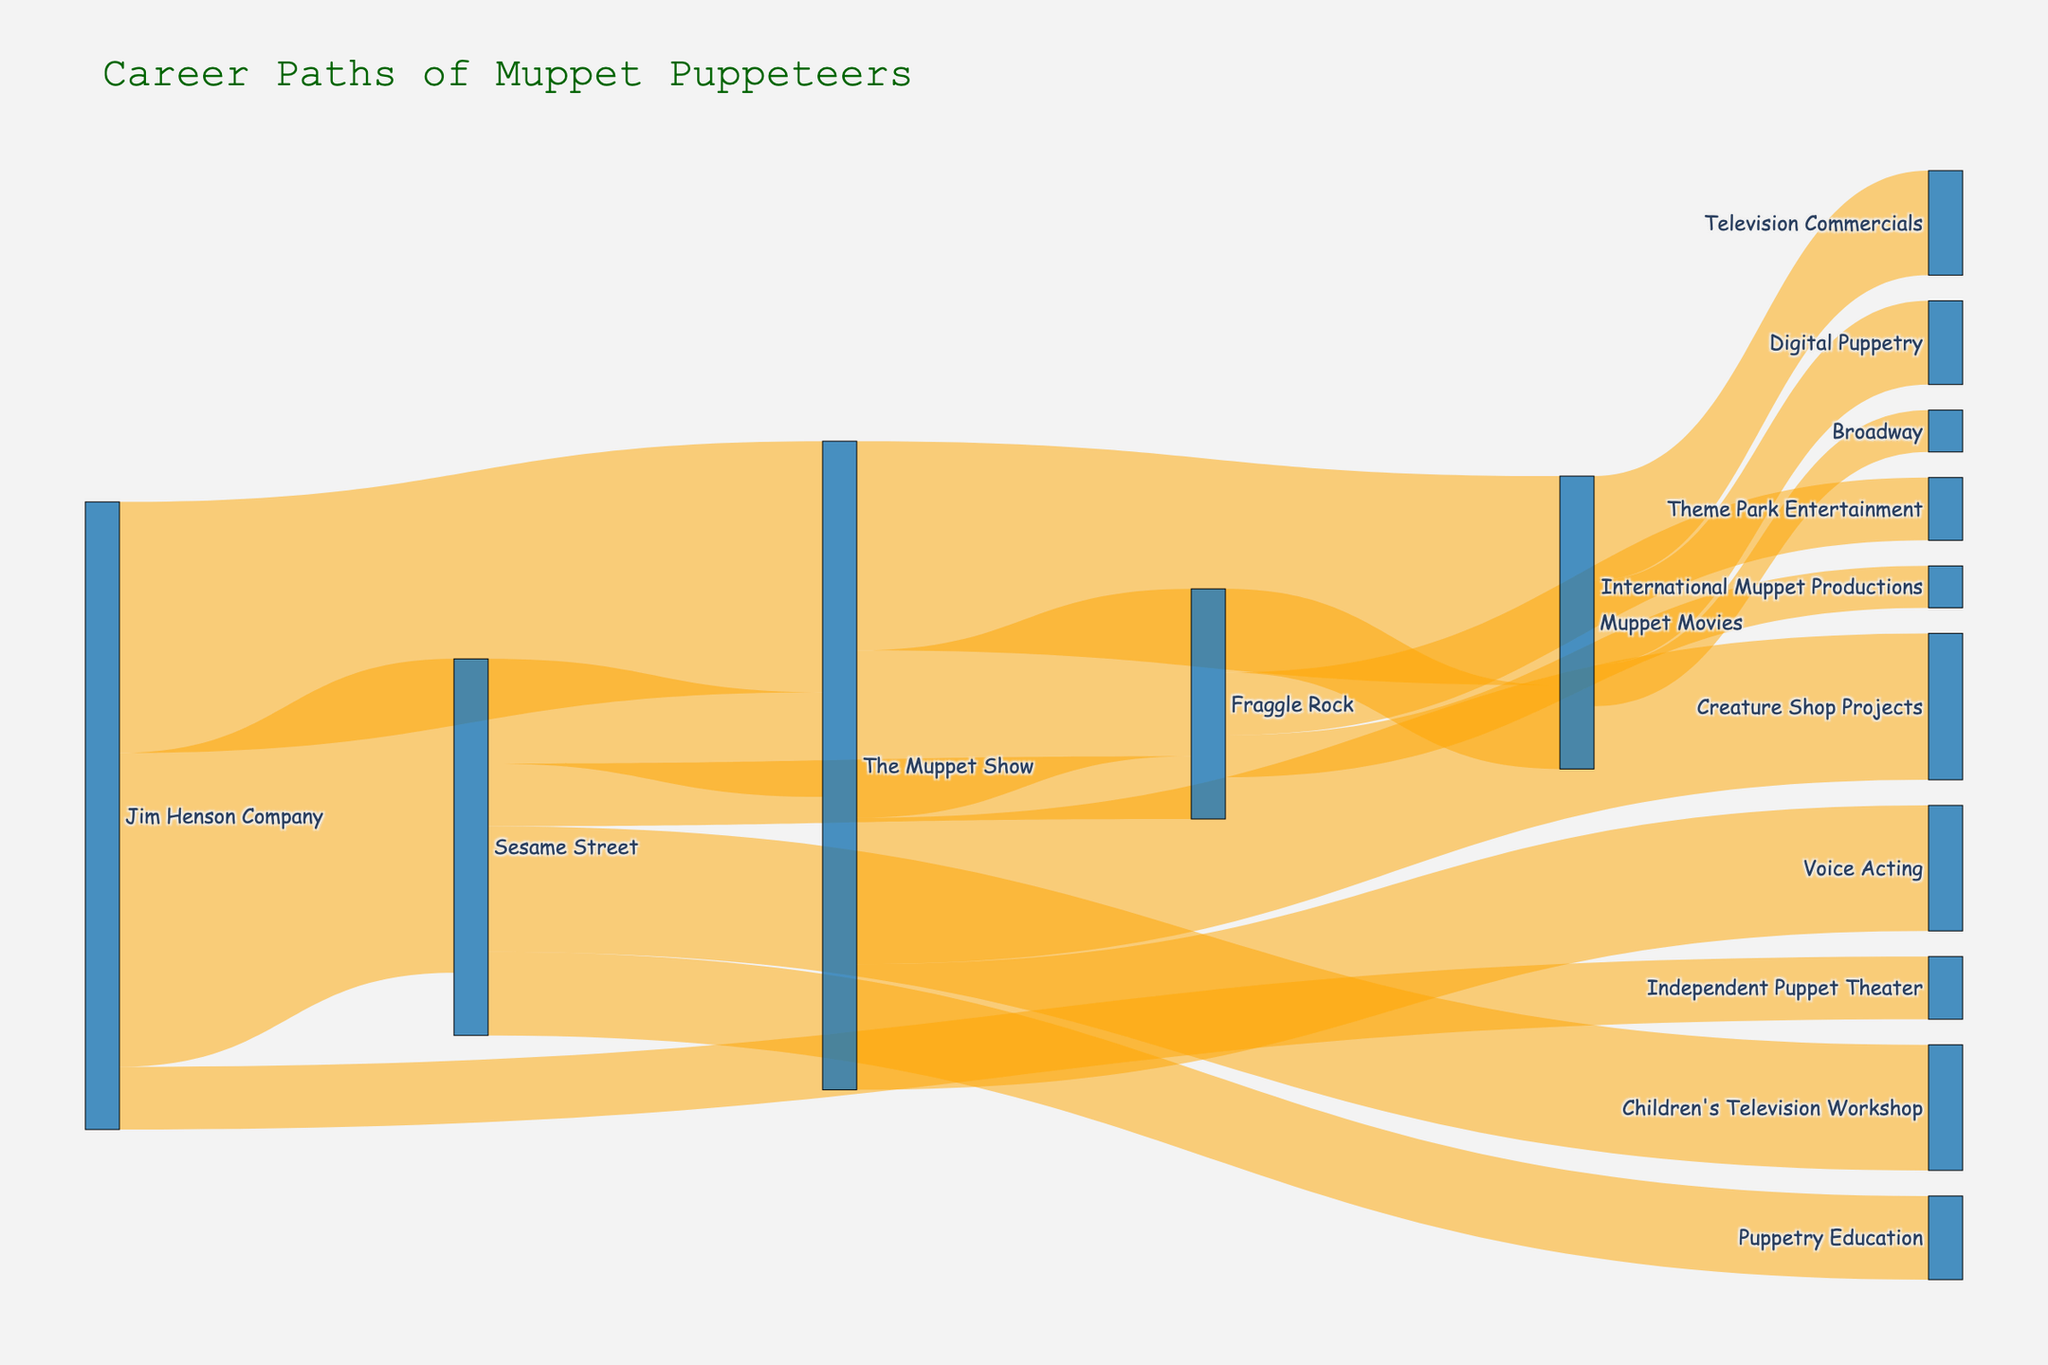How many career transitions from the Jim Henson Company to other entities are shown? There are four transitions starting from the Jim Henson Company: to Sesame Street (15), The Muppet Show (12), Independent Puppet Theater (3), and one to an unspecified location. So there are a total of 4 transitions.
Answer: 4 Which transition has the highest value in the Sankey diagram? Scan through all the 'value' figures associated with different transitions visually. The highest value is from the Jim Henson Company to Sesame Street with a value of 15.
Answer: Jim Henson Company to Sesame Street How many puppeteers transitioned from Sesame Street to either Fraggle Rock or The Muppet Show? The transition value from Sesame Street to Fraggle Rock is 3, and to The Muppet Show is 5. Adding these gives 3 + 5 = 8.
Answer: 8 Between The Muppet Show and Fraggle Rock, which has more transitions to Muppet Movies? The transition value from The Muppet Show to Muppet Movies is 10, and from Fraggle Rock to Muppet Movies is 4. 10 is greater than 4.
Answer: The Muppet Show What is the sum of all transitions originating from The Muppet Show? The transitions originating from The Muppet Show are to Fraggle Rock (8), Muppet Movies (10), Voice Acting (6), and Creature Shop Projects (7). Summing these: 8 + 10 + 6 + 7 = 31.
Answer: 31 Which category has the most diverse career paths (i.e., the most target nodes)? By counting the number of unique target nodes for each source node, The Muppet Show connects to Fraggle Rock, Muppet Movies, Voice Acting, and Creature Shop Projects. It has 4 different targets, the same as the Jim Henson Company. Both have the highest diversity in paths with 4 targets each.
Answer: The Muppet Show and Jim Henson Company What is the difference in transition values between The Muppet Show and Sesame Street leading to Fraggle Rock? The value from The Muppet Show to Fraggle Rock is 8, while from Sesame Street to Fraggle Rock is 3. The difference is 8 - 3 = 5.
Answer: 5 Which production has more puppeteers transitioning into Digital Puppetry, Sesame Street or Muppet Movies? Muppet Movies has a transition value of 4 to Digital Puppetry. Sesame Street doesn't have transitions to Digital Puppetry, so Muppet Movies has more.
Answer: Muppet Movies In terms of sheer numbers, which career path is more common: transitioning from The Muppet Show to Muppet Movies or from Jim Henson Company to The Muppet Show? The transition from The Muppet Show to Muppet Movies has a value of 10, while from Jim Henson Company to The Muppet Show has a value of 12.
Answer: Jim Henson Company to The Muppet Show 